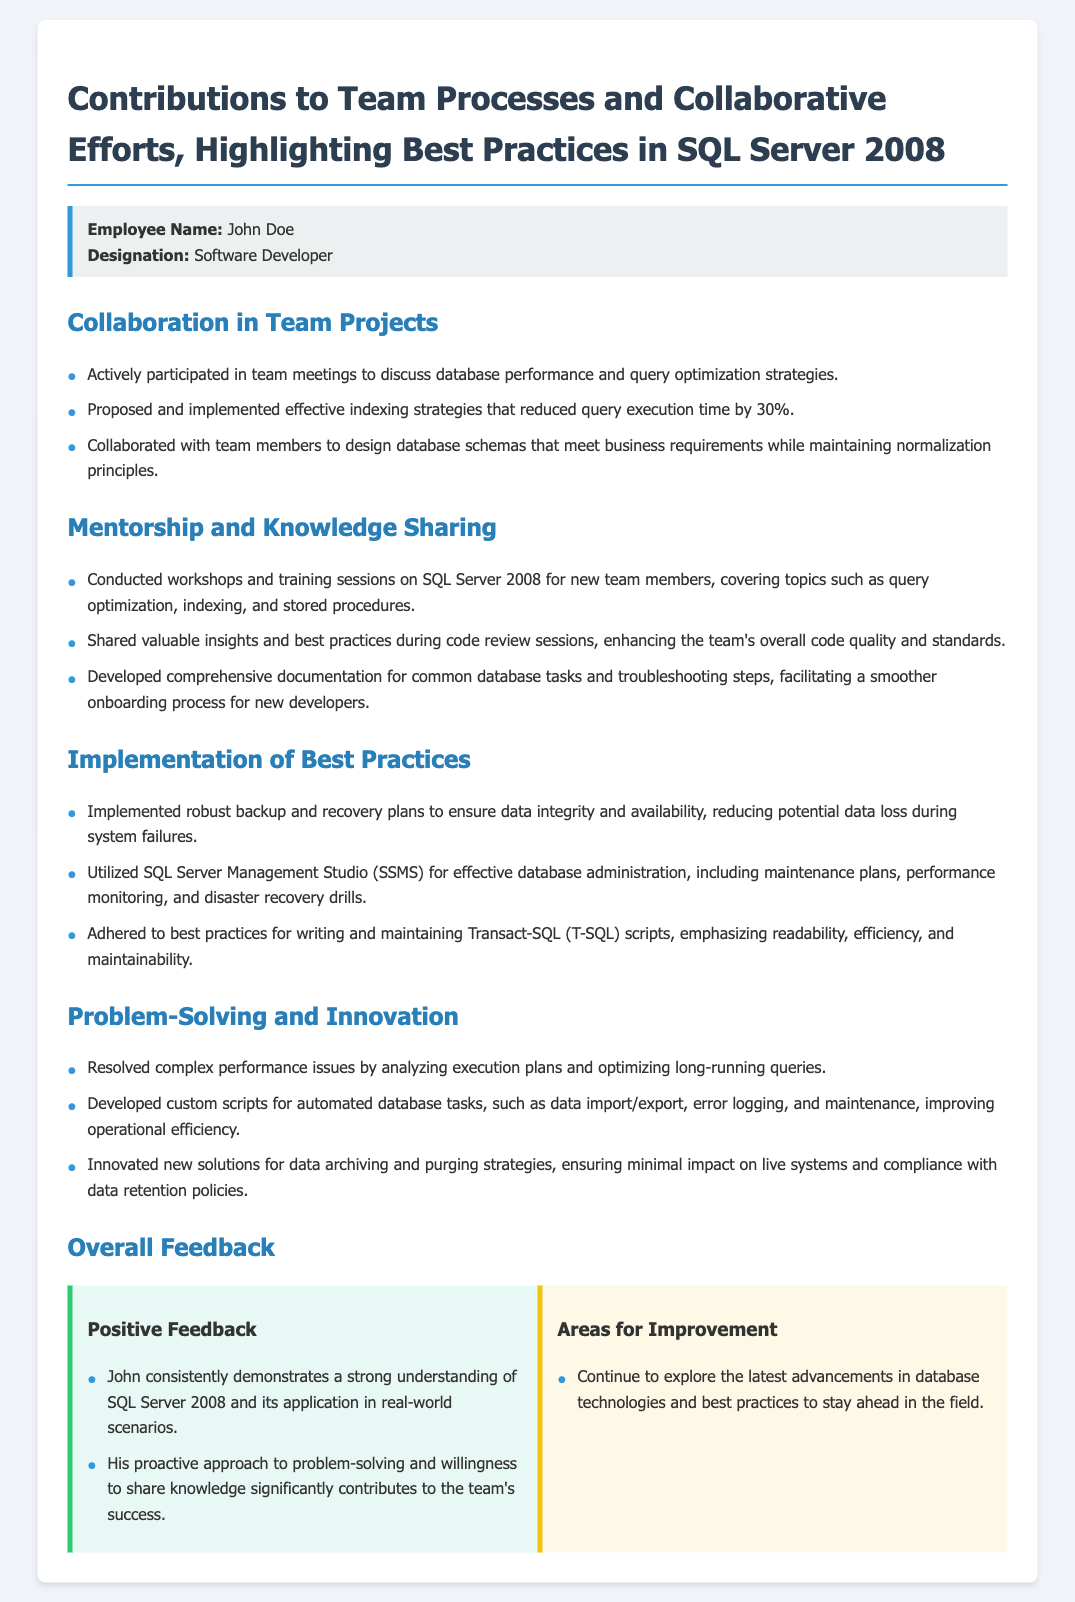what is the employee's name? The employee's name is provided in the employee information section of the appraisal form.
Answer: John Doe who conducted workshops on SQL Server 2008? The document states that the employee conducted workshops for new team members.
Answer: John Doe what percentage did query execution time reduce by implementing effective indexing strategies? The document specifies the impact of indexing strategies implemented by the employee on query execution time.
Answer: 30% what is one area for improvement mentioned in the feedback section? The feedback section lists areas for improvement related to staying updated in the field.
Answer: Latest advancements what tool is mentioned for effective database administration? The document refers specifically to a tool used for database administration activities.
Answer: SQL Server Management Studio how many key sections are listed under Contributions to Team Processes? The document highlights several key areas related to teamwork and collaboration.
Answer: Four what type of training sessions did the employee conduct? The document describes the nature of the training sessions provided by the employee.
Answer: Workshops which principle was emphasized while designing database schemas? The document mentions a core principle that was adhered to while designing schemas.
Answer: Normalization principles what is the feedback type for John Doe's strong understanding of SQL Server? The feedback regarding John's performance is categorized under a specific type in the document.
Answer: Positive Feedback 